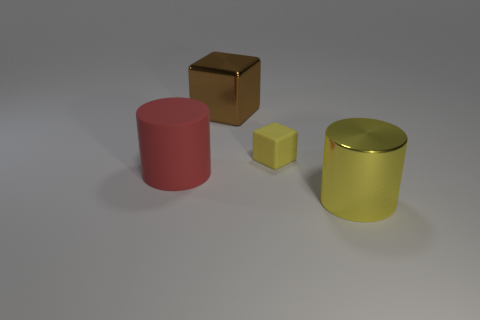Add 3 blue metal balls. How many objects exist? 7 Subtract 0 brown cylinders. How many objects are left? 4 Subtract all red blocks. Subtract all rubber objects. How many objects are left? 2 Add 1 large brown shiny things. How many large brown shiny things are left? 2 Add 4 red things. How many red things exist? 5 